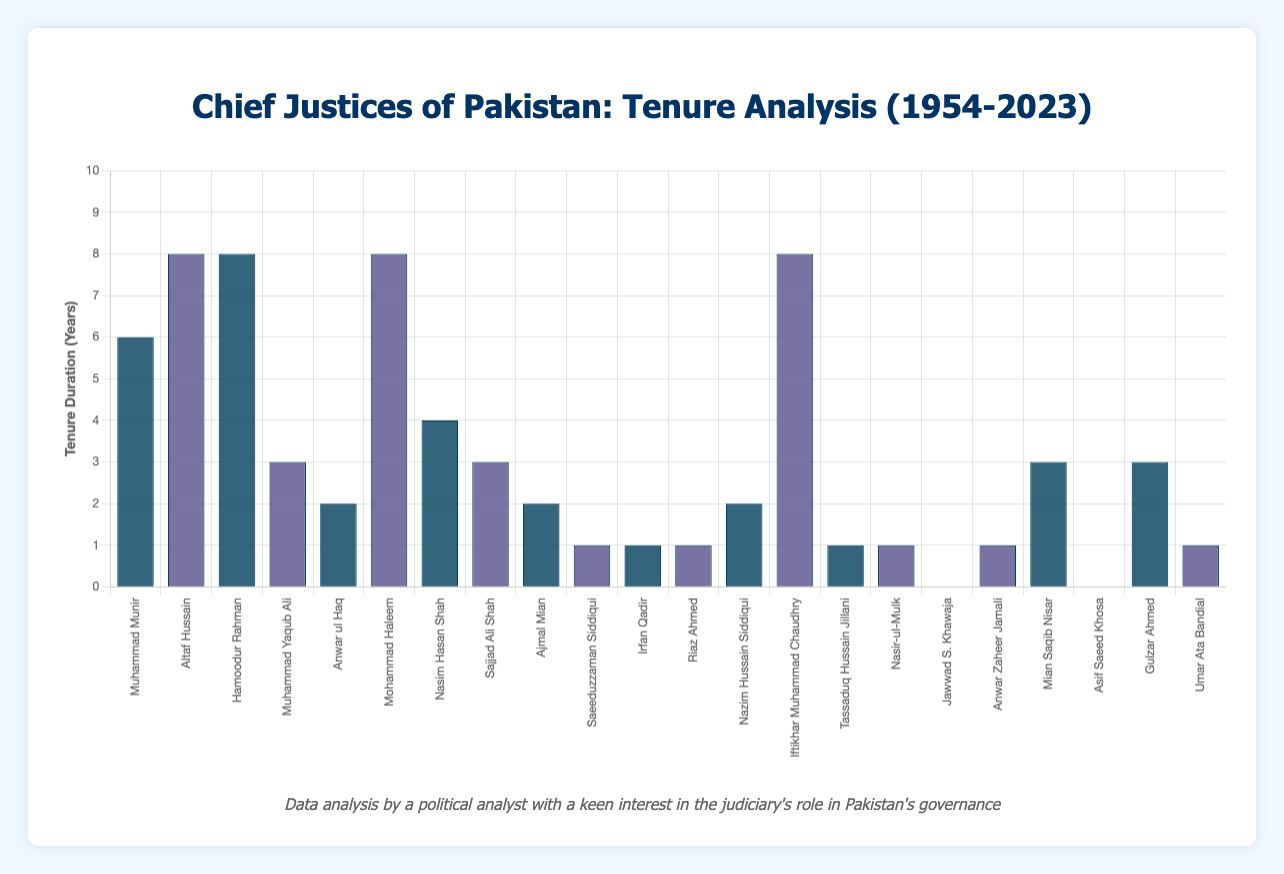Which Chief Justice had the longest tenure? By examining the heights of the bars, the Chief Justice with the highest bar represents the longest tenure. This corresponds to Altaf Hussain, Hamoodur Rahman, Mohammad Haleem, and Iftikhar Muhammad Chaudhry, all having 8-year tenure bars.
Answer: Altaf Hussain, Hamoodur Rahman, Mohammad Haleem, and Iftikhar Muhammad Chaudhry Which Chief Justice had the shortest tenure? By looking at the shortest bars, Jawwad S. Khawaja and Asif Saeed Khosa both held the position for the shortest duration of 0 years.
Answer: Jawwad S. Khawaja and Asif Saeed Khosa What is the combined tenure duration of the Chief Justices from 1954 to 1976? Sum the tenure durations of Muhammad Munir (6 years), Altaf Hussain (8 years), and Hamoodur Rahman (8 years): 6 + 8 + 8 = 22 years.
Answer: 22 years How many Chief Justices served for exactly 1 year? Count the bars with a height corresponding to a 1-year tenure: Saeeduzzaman Siddiqui, Irfan Qadir, Riaz Ahmed, Tassaduq Hussain Jillani, Nasir-ul-Mulk, Anwar Zaheer Jamali, and Umar Ata Bandial.
Answer: 7 Did more Chief Justices serve for 3 years or for 8 years? Compare the number of bars for 3-year tenures (Muhammad Yaqub Ali, Sajjad Ali Shah, Mian Saqib Nisar, Gulzar Ahmed) and 8-year tenures (Altaf Hussain, Hamoodur Rahman, Mohammad Haleem, Iftikhar Muhammad Chaudhry). Both groups have 4 Chief Justices each.
Answer: Equal, both have 4 Which period had the highest frequency of Chief Justices changing, the 1970s or the 2010s? Count the number of Chief Justices serving in the 1970s (Hamoodur Rahman, Muhammad Yaqub Ali, Anwar ul Haq) and the 2010s (Iftikhar Muhammad Chaudhry, Tassaduq Hussain Jillani, Nasir-ul-Mulk, Jawwad S. Khawaja, Anwar Zaheer Jamali, Mian Saqib Nisar, Asif Saeed Khosa, Gulzar Ahmed). The 2010s had more frequent changes.
Answer: 2010s What is the average duration of tenures for Chief Justices who served in the 2000s? Add the tenure durations for Nasim Hasan Shah (4), Sajjad Ali Shah (3), Ajmal Mian (2), Saeeduzzaman Siddiqui (1), Irfan Qadir (1), Riaz Ahmed (1), Nazim Hussain Siddiqui (2), Iftikhar Muhammad Chaudhry (8), divide by the number of Chief Justices (8): (4 + 3 + 2 + 1 + 1 + 1 + 2 + 8)/8 = 22/8 = 2.75 years.
Answer: 2.75 years Which Chief Justice's tenure included the transition from one decade to another? Identify Chief Justices whose tenure spans across decades. Hamoodur Rahman's (1968-1976), Mohammad Haleem's (1981-1989), Iftikhar Muhammad Chaudhry's (2005-2013) tenures include such transitions.
Answer: Hamoodur Rahman, Mohammad Haleem, Iftikhar Muhammad Chaudhry 